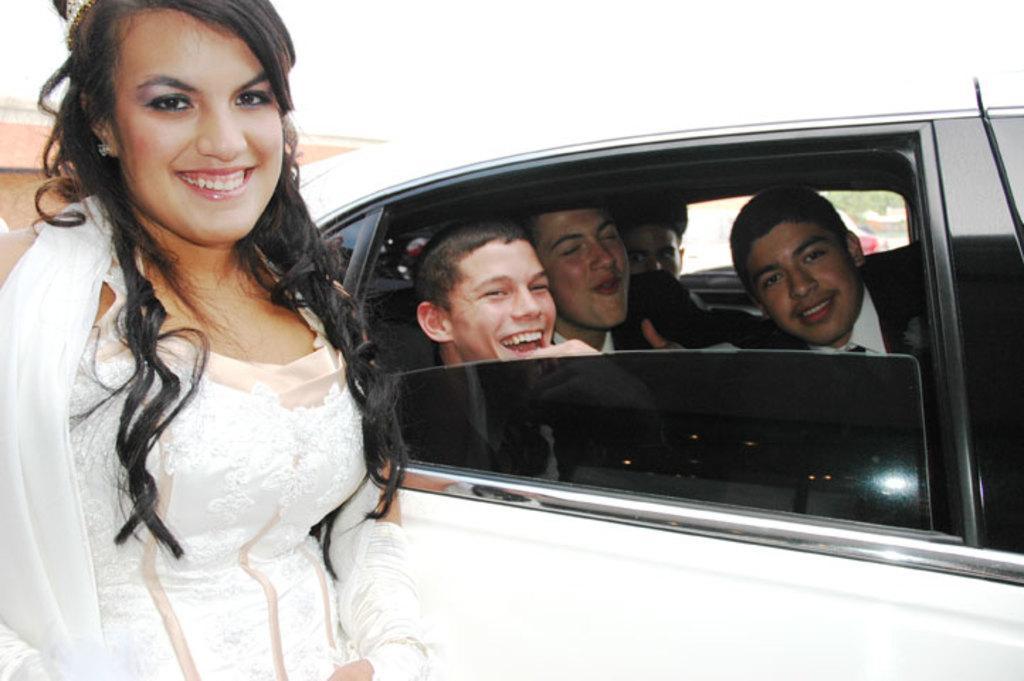How would you summarize this image in a sentence or two? In the picture we can see a woman standing near the car, in the car we can see four boys smiling, a car is white in color with black glass, and the woman is wearing a white dress, she is also smiling. 